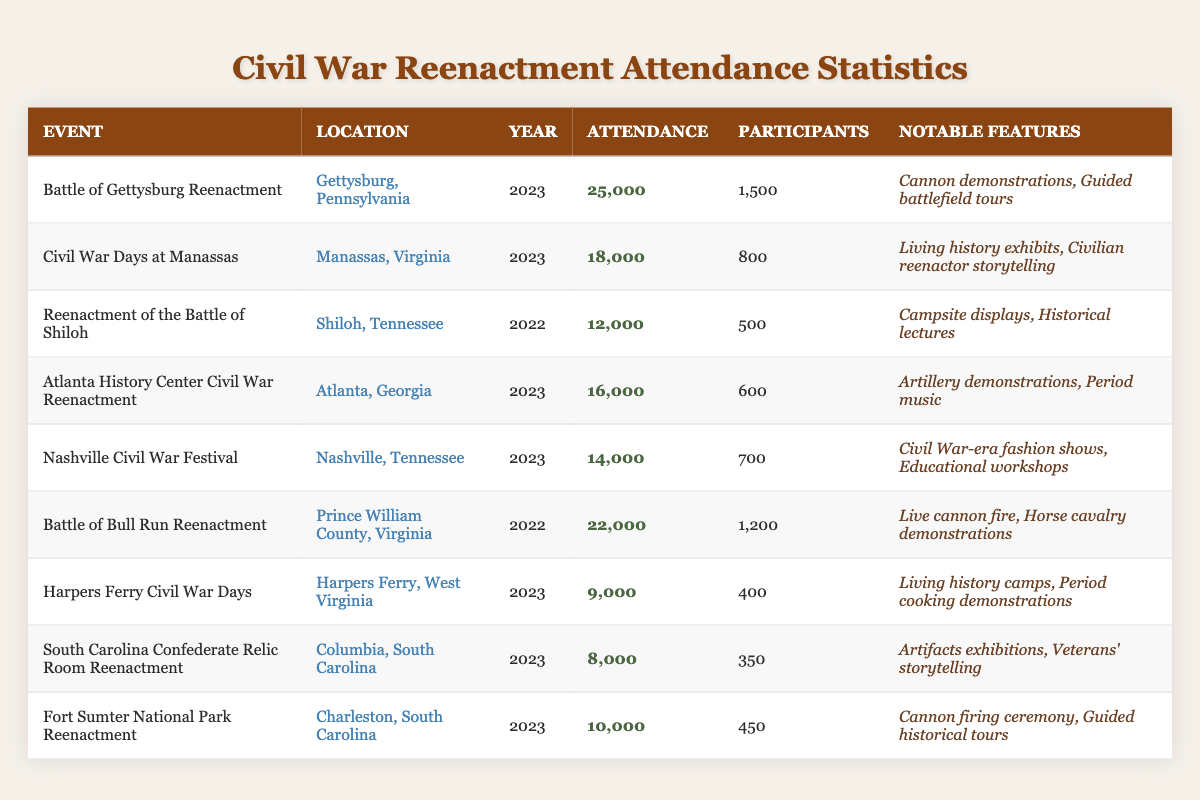What was the attendance at the Battle of Gettysburg Reenactment in 2023? Referring to the table, the attendance at the Battle of Gettysburg Reenactment in 2023 is listed as 25,000.
Answer: 25,000 How many participants were there at the Atlanta History Center Civil War Reenactment? The table shows that there were 600 participants at the Atlanta History Center Civil War Reenactment.
Answer: 600 Which event had the highest attendance, and what was the number? From the table, the event with the highest attendance is the Battle of Gettysburg Reenactment with an attendance of 25,000.
Answer: Battle of Gettysburg Reenactment, 25,000 What is the average attendance of the reenactments listed in the table? To find the average, first sum all the attendances: (25,000 + 18,000 + 12,000 + 16,000 + 14,000 + 22,000 + 9,000 + 8,000 + 10,000) = 234,000. There are 9 events, so the average is 234,000 / 9 = 26,000.
Answer: 26,000 Did any event in South Carolina have an attendance of over 10,000? By looking at the table, the Fort Sumter National Park Reenactment in Charleston shows an attendance of 10,000, while the South Carolina Confederate Relic Room Reenactment had 8,000. Therefore, only Fort Sumter reached exactly 10,000.
Answer: Yes What year did the Battle of Bull Run Reenactment take place, and how many participants were there? The table indicates that the Battle of Bull Run Reenactment took place in 2022, with 1,200 participants.
Answer: 2022, 1,200 If you combine the attendance of the reenactments in Tennessee, what is the total? Referring to the table, the attendance for the Reenactment of the Battle of Shiloh is 12,000 and for the Nashville Civil War Festival is 14,000. Summing these gives us 12,000 + 14,000 = 26,000.
Answer: 26,000 Which event had the least attendance, and what was the number of participants? The event with the least attendance is the South Carolina Confederate Relic Room Reenactment with 8,000 attendees and 350 participants.
Answer: South Carolina Confederate Relic Room Reenactment, 8,000, 350 Is there any event listed for the year 2022 that had an attendance of over 20,000? The Battle of Bull Run Reenactment took place in 2022 with an attendance of 22,000. Therefore, it meets the criteria.
Answer: Yes What notable features were associated with the Nashville Civil War Festival? According to the table, the notable features for the Nashville Civil War Festival include Civil War-era fashion shows and educational workshops.
Answer: Civil War-era fashion shows, educational workshops Calculate the difference in attendance between the Battle of Bull Run Reenactment and the Civil War Days at Manassas. The Battle of Bull Run Reenactment had 22,000 attendees and Civil War Days at Manassas had 18,000; the difference is 22,000 - 18,000 = 4,000.
Answer: 4,000 